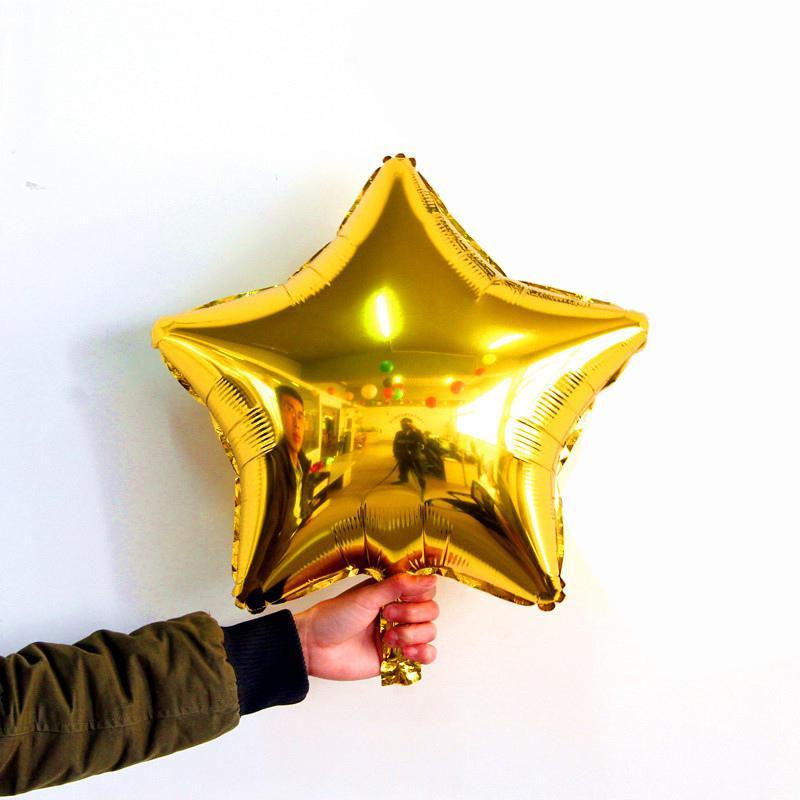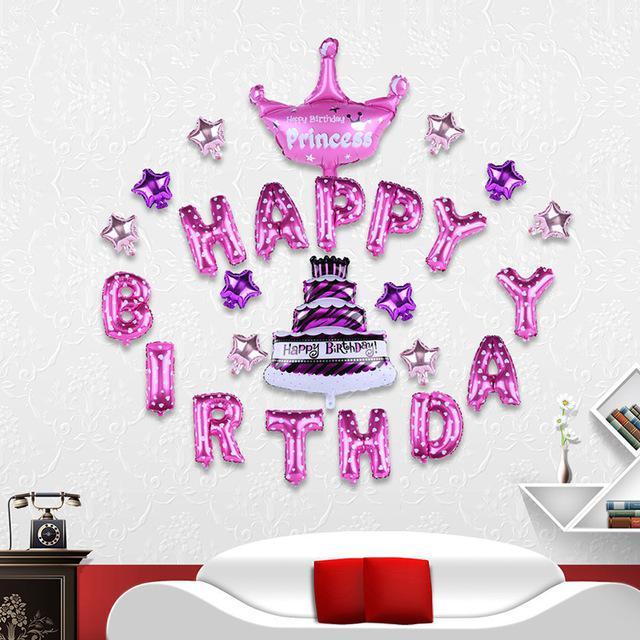The first image is the image on the left, the second image is the image on the right. For the images displayed, is the sentence "Each image includes at least one star-shaped balloon, and at least one image includes multiple colors of star balloons, including gold, green, red, and blue." factually correct? Answer yes or no. No. The first image is the image on the left, the second image is the image on the right. Considering the images on both sides, is "IN at least one image there is a single star balloon." valid? Answer yes or no. Yes. 